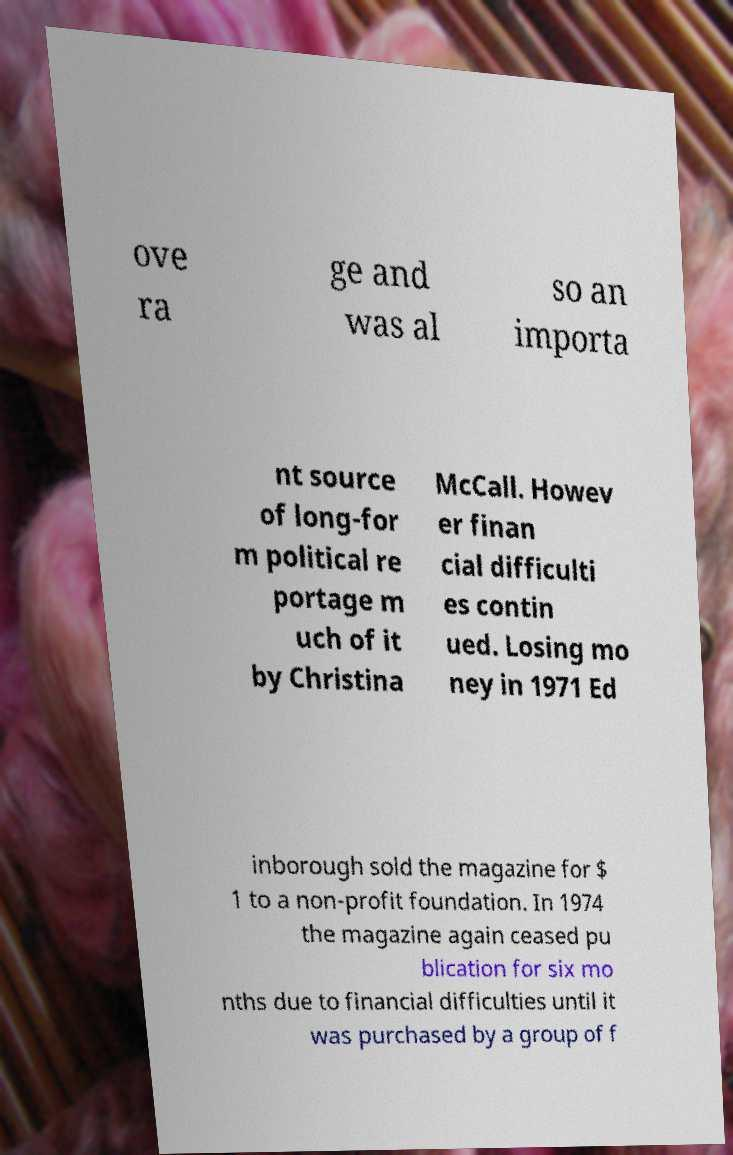There's text embedded in this image that I need extracted. Can you transcribe it verbatim? ove ra ge and was al so an importa nt source of long-for m political re portage m uch of it by Christina McCall. Howev er finan cial difficulti es contin ued. Losing mo ney in 1971 Ed inborough sold the magazine for $ 1 to a non-profit foundation. In 1974 the magazine again ceased pu blication for six mo nths due to financial difficulties until it was purchased by a group of f 